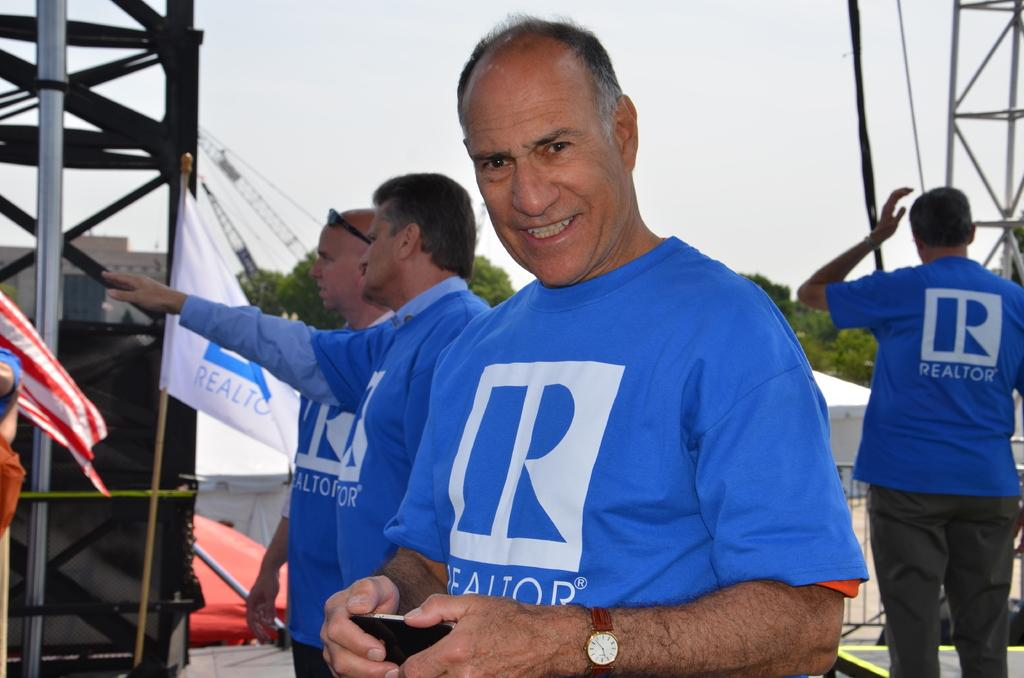<image>
Write a terse but informative summary of the picture. several men wearing blue t-shirts with Realtor on them 